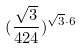<formula> <loc_0><loc_0><loc_500><loc_500>( \frac { \sqrt { 3 } } { 4 2 4 } ) ^ { \sqrt { 3 } \cdot 6 }</formula> 